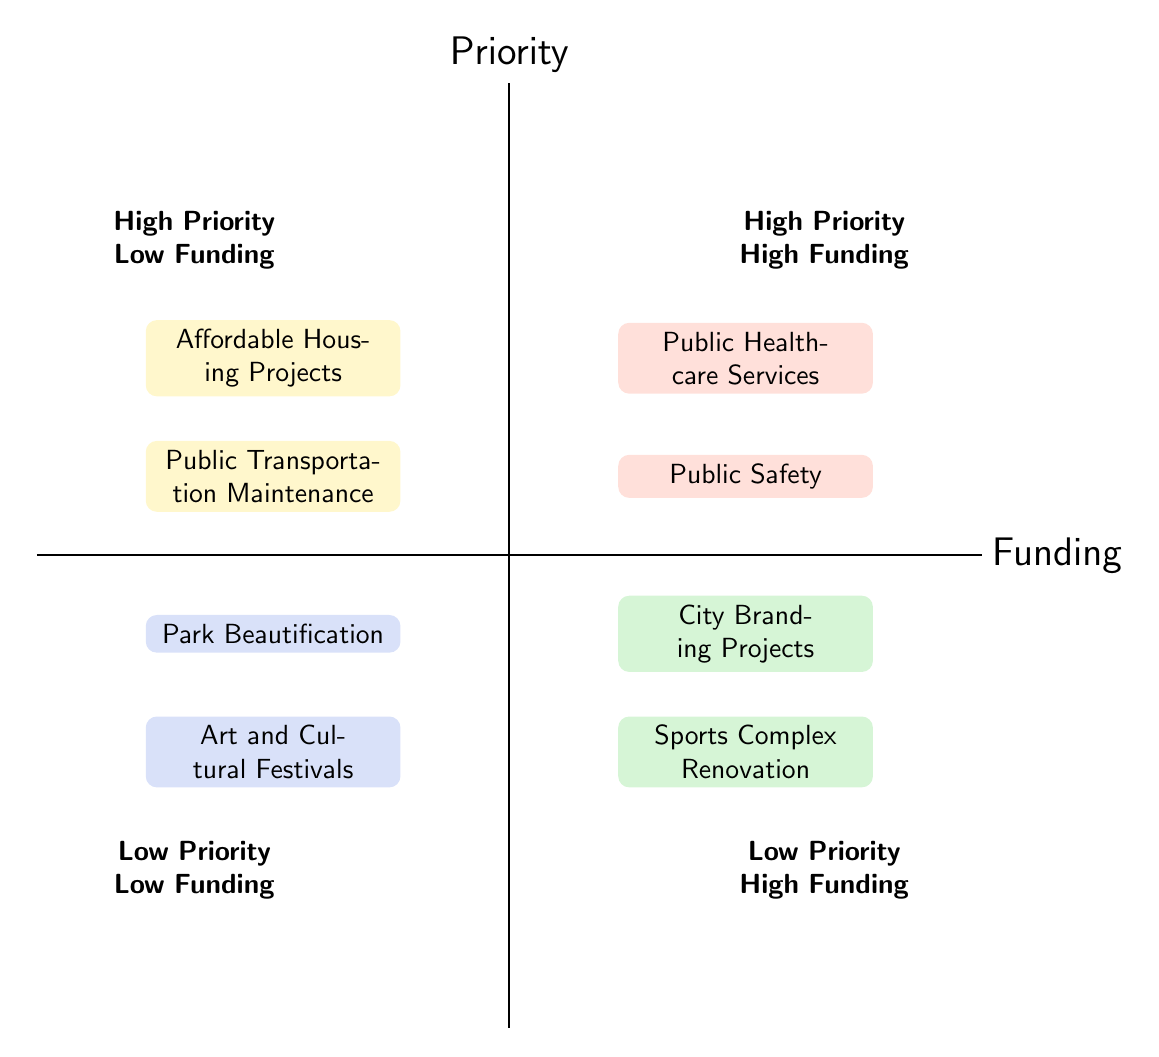What are the two services in the "High Priority, High Funding" quadrant? This quadrant contains the services that are both highly prioritized and well-funded. By identifying the nodes, the two services listed are "Public Healthcare Services" and "Public Safety".
Answer: Public Healthcare Services, Public Safety How many projects fall under "Low Priority, Low Funding"? In this quadrant, there are two nodes present, which represent the initiatives with low priority and low funding. Counting the nodes gives a total of two projects.
Answer: 2 What is the description of "Affordable Housing Projects"? To find the requested description, we look in the "High Priority, Low Funding" quadrant and identify the description associated with "Affordable Housing Projects". It aims to provide affordable housing options to low-income families and reduce homelessness.
Answer: Initiatives to provide affordable housing options to low-income families and reduce homelessness Which quadrant has "Sports Complex Renovation"? The "Sports Complex Renovation" falls in the "Low Priority, High Funding" quadrant. We can determine this by checking its position in the diagram, which categorizes it as low priority despite the high funding allocation.
Answer: Low Priority, High Funding How does "Public Transportation Maintenance" compare to "Public Safety"? "Public Transportation Maintenance" is located in the "High Priority, Low Funding" quadrant while "Public Safety" is in the "High Priority, High Funding" quadrant. This indicates that both are of high priority, but "Public Safety" receives more funding compared to "Public Transportation Maintenance".
Answer: High Priority, High Funding vs. High Priority, Low Funding Which project is least prioritized and has the least funding? Referring to the "Low Priority, Low Funding" quadrant, we identify the projects here. Among them, both projects are low priority and low funding, but they can both be considered equal in this category.
Answer: Art and Cultural Festivals, Park Beautification Which quadrant includes projects aimed at community enhancement but are considered low priority? These projects are found in the "Low Priority, Low Funding" quadrant. On reviewing the content of this quadrant, both included projects focus on enhancing community spirit through cultural events and park improvements.
Answer: Low Priority, Low Funding What are the two projects with high funding but low priority? In the "Low Priority, High Funding" quadrant, the projects listed are "Sports Complex Renovation" and "City Branding Projects." These reflect significant funding for initiatives that are not prioritized highly.
Answer: Sports Complex Renovation, City Branding Projects How many services receive high funding? By analyzing the quadrants, we find two services in the "High Priority, High Funding" quadrant and two in the "Low Priority, High Funding" quadrant. Therefore, the total number of services receiving high funding is four.
Answer: 4 